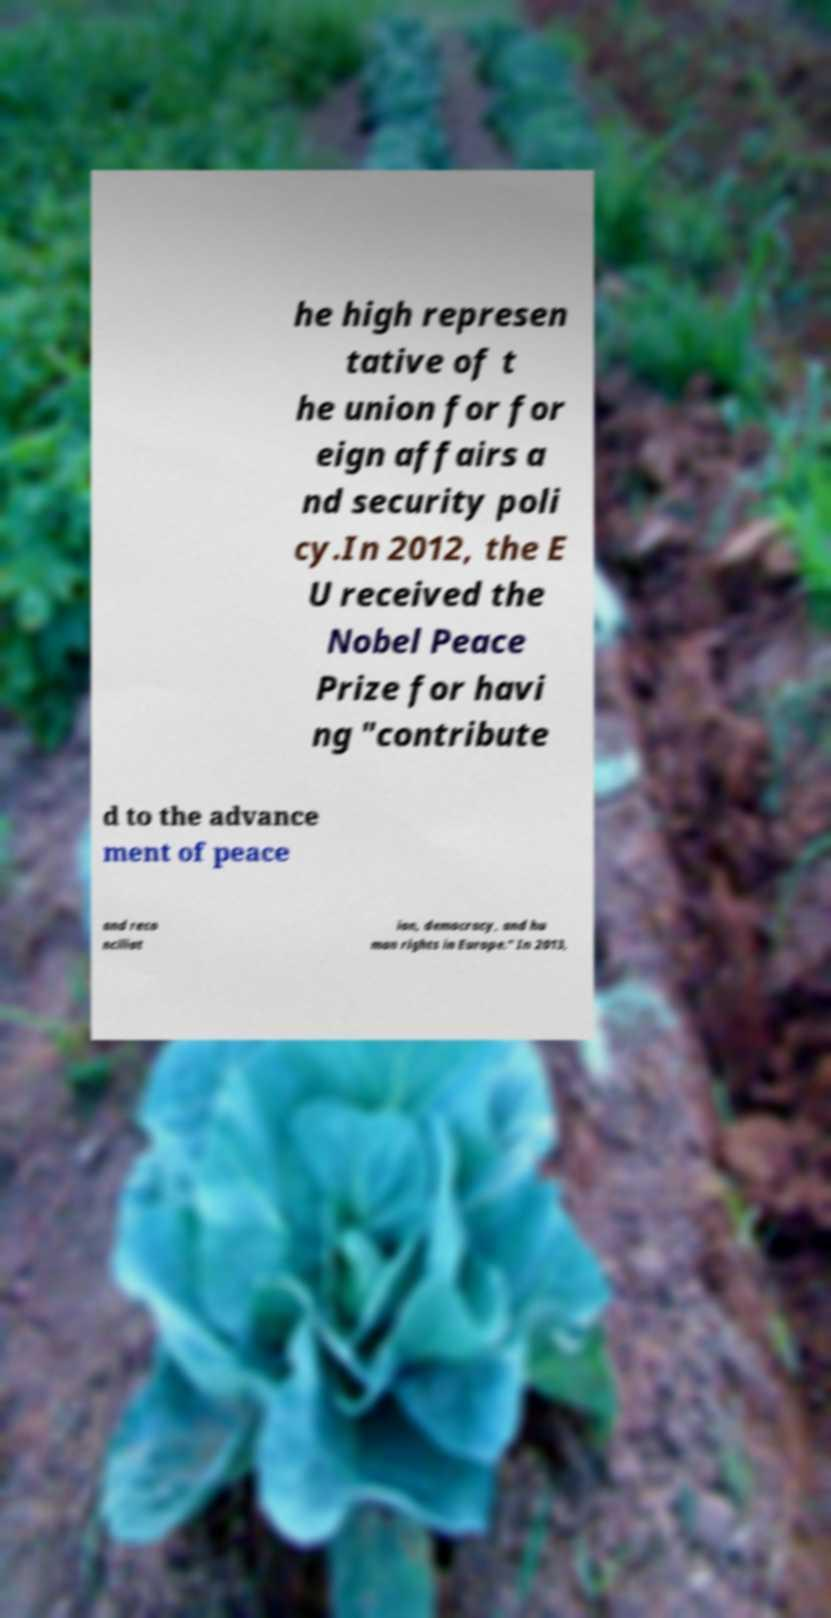Please read and relay the text visible in this image. What does it say? he high represen tative of t he union for for eign affairs a nd security poli cy.In 2012, the E U received the Nobel Peace Prize for havi ng "contribute d to the advance ment of peace and reco nciliat ion, democracy, and hu man rights in Europe." In 2013, 